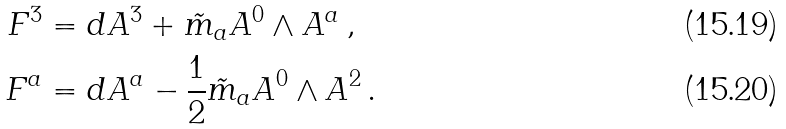Convert formula to latex. <formula><loc_0><loc_0><loc_500><loc_500>F ^ { 3 } & = d A ^ { 3 } + \tilde { m } _ { a } A ^ { 0 } \wedge A ^ { a } \, , \\ F ^ { a } & = d A ^ { a } - \frac { 1 } { 2 } \tilde { m } _ { a } A ^ { 0 } \wedge A ^ { 2 } \, .</formula> 